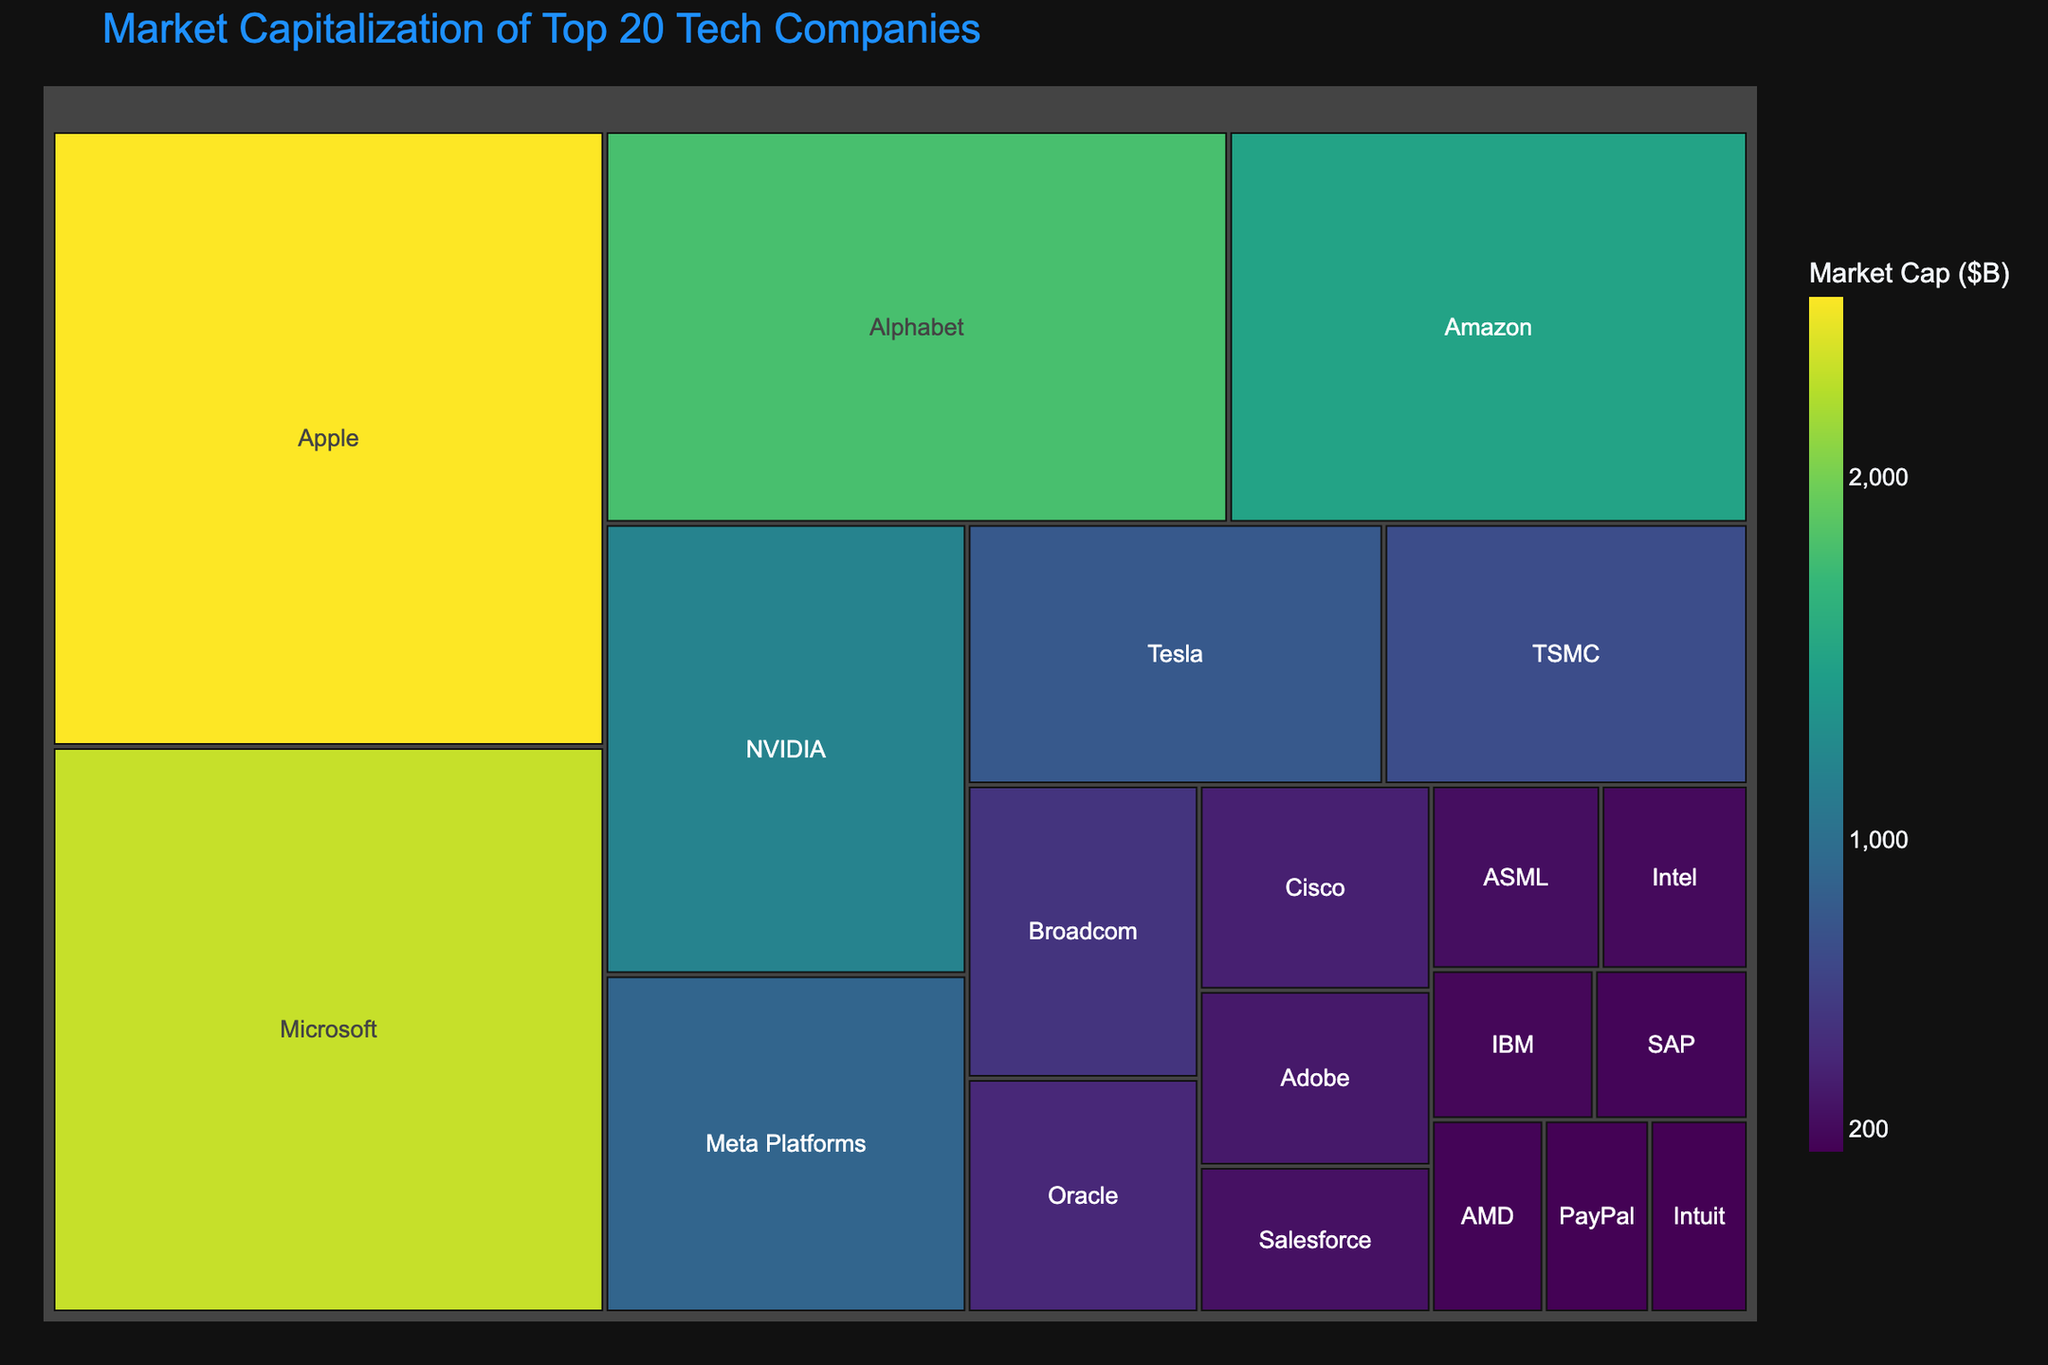What is the title of the treemap? The title is displayed at the top center of the treemap. It provides a summary of what the treemap represents.
Answer: Market Capitalization of Top 20 Tech Companies Which company has the highest market capitalization? Look for the largest rectangle in the treemap, which represents the company with the highest market capitalization value.
Answer: Apple How many companies have a market capitalization greater than $1 trillion? Identify the companies with large rectangles and use the hover data to check if the MarketCap exceeds $1 trillion.
Answer: 4 What's the combined market capitalization of Apple and Microsoft? Find the market capitalization of Apple ($2,500,000M) and Microsoft ($2,300,000M) and sum them up: $2,500,000M + $2,300,000M.
Answer: $4,800,000M Which company has the smallest market capitalization among the top 20? Locate the smallest rectangle in the treemap and check the company label.
Answer: Intuit How does the market capitalization of Alphabet compare to that of Amazon? Identify the rectangles for Alphabet and Amazon, compare their sizes and the hover data showing Alphabet ($1,800,000M) and Amazon ($1,500,000M).
Answer: Alphabet has a higher market capitalization than Amazon What's the total market capitalization of the top 5 companies? Identify the top 5 companies by their MarketCap: Apple, Microsoft, Alphabet, Amazon, and NVIDIA. Sum their market values: $2,500,000M + $2,300,000M + $1,800,000M + $1,500,000M + $1,200,000M.
Answer: $9,300,000M Which companies have a market capitalization between $200B and $500B? Examine rectangles with hover data showing market cap values within the $200,000M - $500,000M range.
Answer: Broadcom, Oracle, Cisco, Adobe What is the difference in market capitalization between Meta Platforms and NVIDIA? Find the values for Meta Platforms ($900,000M) and NVIDIA ($1,200,000M) and subtract: $1,200,000M - $900,000M.
Answer: $300,000M Which company among the top 10 has the lowest market capitalization? From the 10 largest rectangles, identify the one with the smallest market cap via hover data.
Answer: TSMC 